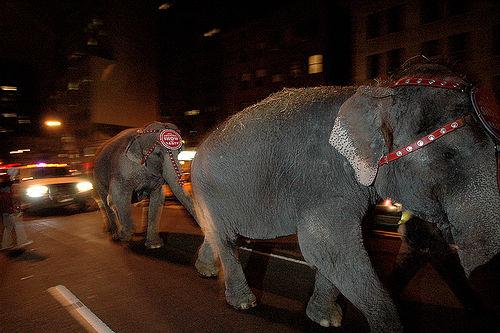How many elephants are in the photo?
Concise answer only. 2. Is it night time?
Answer briefly. Yes. What do the elephants have on their heads?
Write a very short answer. Headdress. What color is above truck cab?
Keep it brief. White. How is the elephant decorated?
Answer briefly. Headband. 